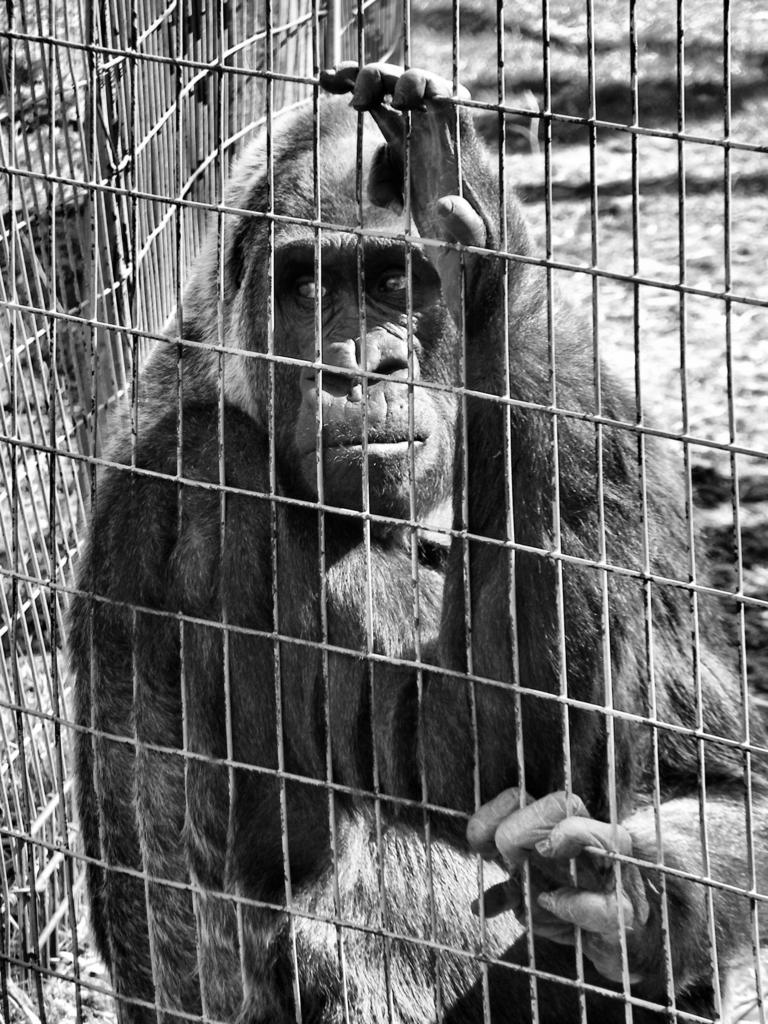What animal is present in the image? There is a chimpanzee in the image. Where is the chimpanzee located? The chimpanzee is in a cage. What is the color scheme of the image? The image is in black and white. What type of cork can be seen in the image? There is no cork present in the image. Can you see any ghosts in the image? There are no ghosts present in the image. 